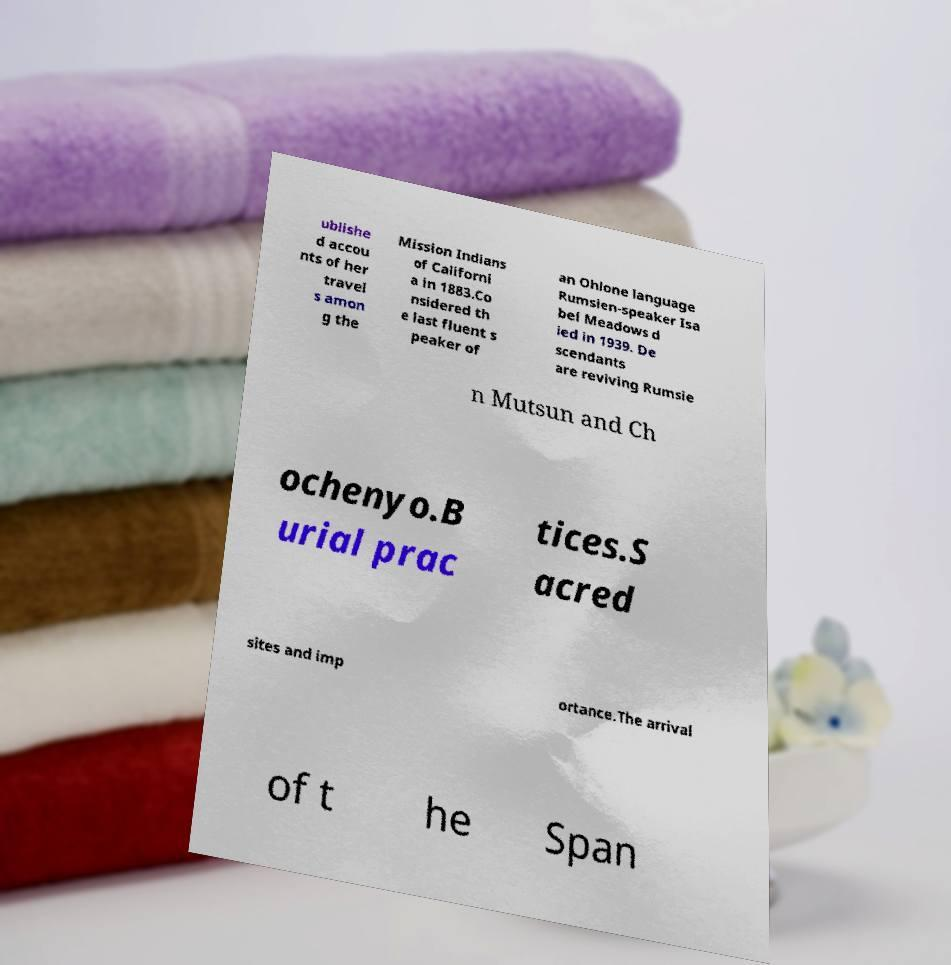Could you assist in decoding the text presented in this image and type it out clearly? ublishe d accou nts of her travel s amon g the Mission Indians of Californi a in 1883.Co nsidered th e last fluent s peaker of an Ohlone language Rumsien-speaker Isa bel Meadows d ied in 1939. De scendants are reviving Rumsie n Mutsun and Ch ochenyo.B urial prac tices.S acred sites and imp ortance.The arrival of t he Span 